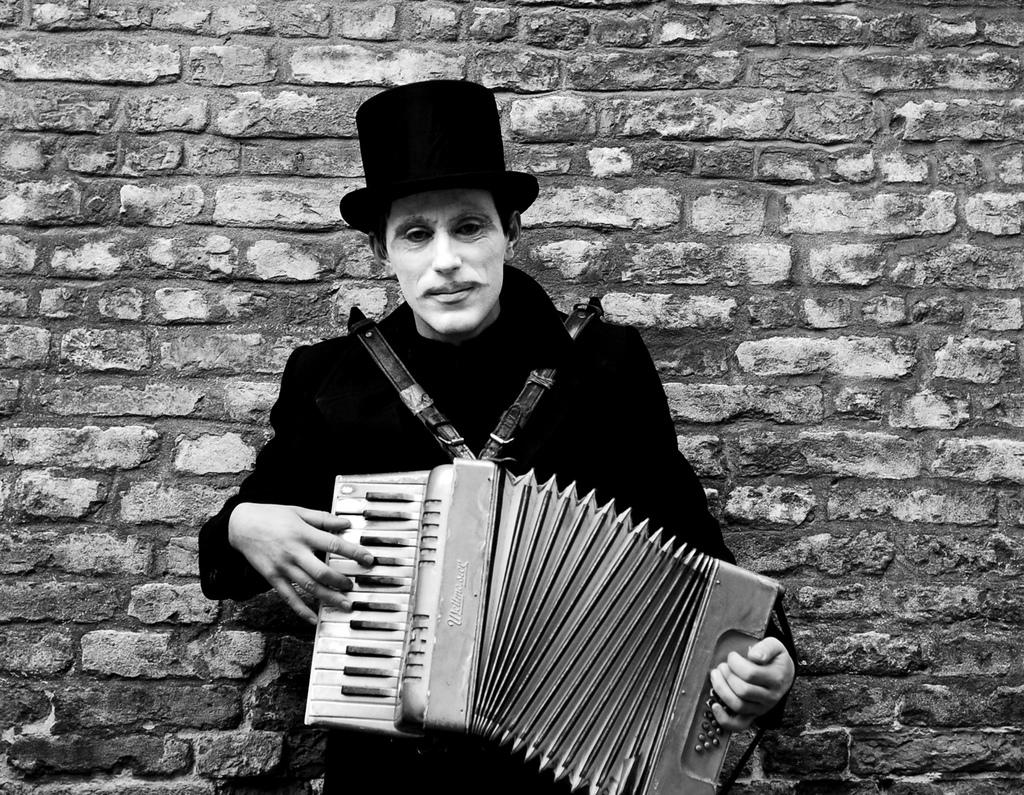What is the main subject of the image? The main subject of the image is a man. What is the man wearing in the image? The man is wearing a hat in the image. What is the man doing in the image? The man is playing a musical instrument in the image. What can be seen behind the man in the image? There is a wall visible behind the man in the image. What type of robin can be seen perched on the man's shoulder in the image? There is no robin present in the image; the man is playing a musical instrument without any birds visible. What prose is the man reciting while playing the musical instrument in the image? There is no indication in the image that the man is reciting any prose while playing the musical instrument. 